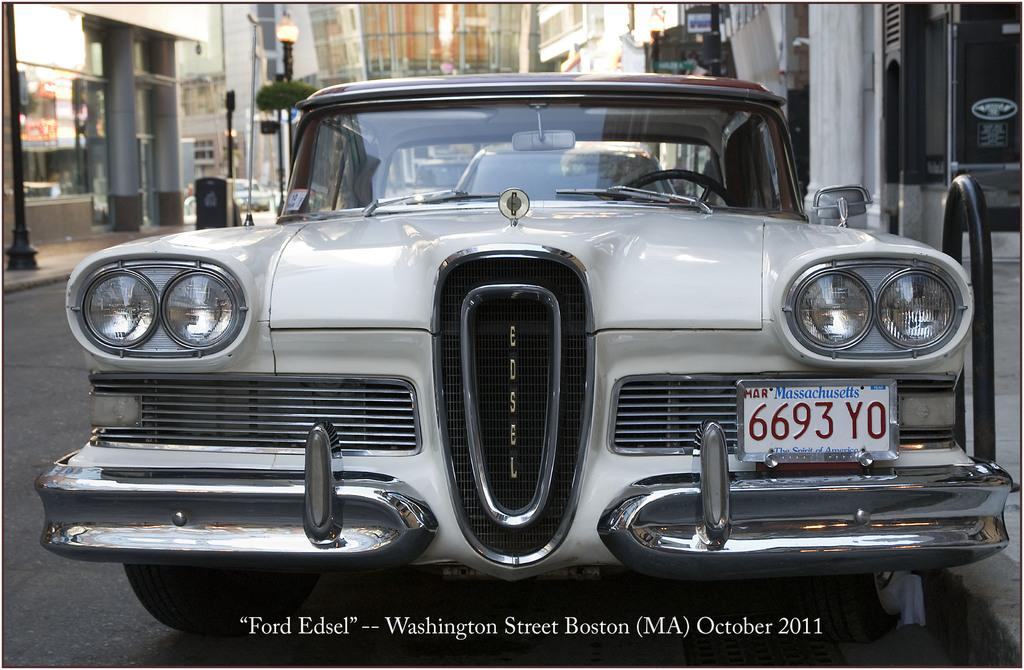<image>
Provide a brief description of the given image. A white car with a Massachusetts license plate is parked on the street. 